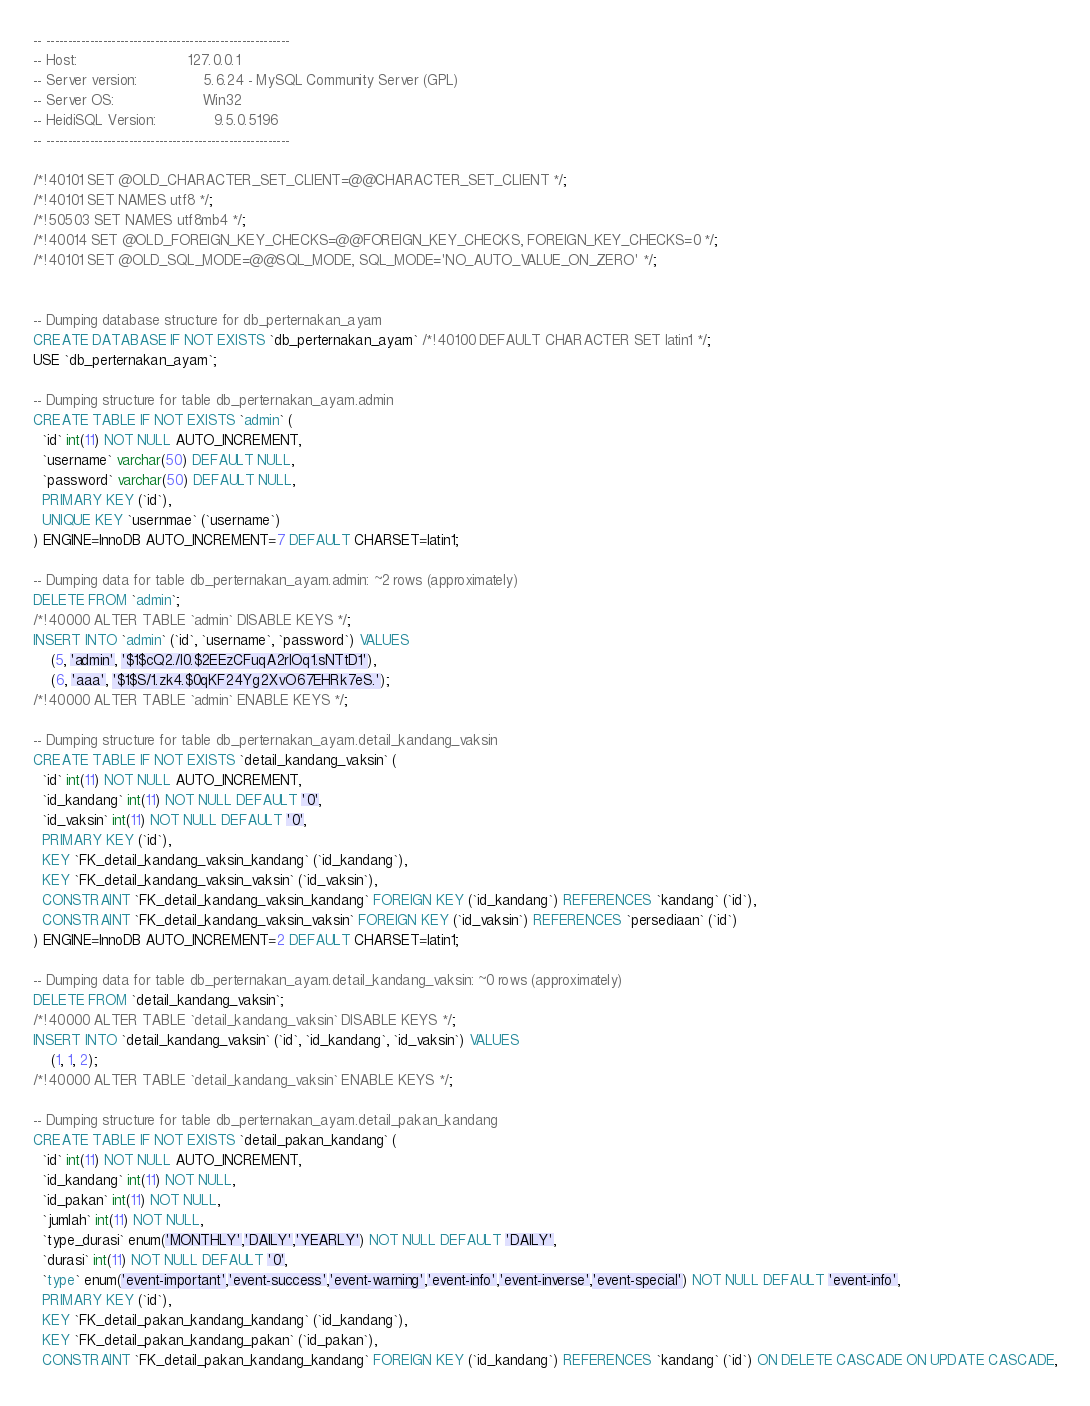Convert code to text. <code><loc_0><loc_0><loc_500><loc_500><_SQL_>-- --------------------------------------------------------
-- Host:                         127.0.0.1
-- Server version:               5.6.24 - MySQL Community Server (GPL)
-- Server OS:                    Win32
-- HeidiSQL Version:             9.5.0.5196
-- --------------------------------------------------------

/*!40101 SET @OLD_CHARACTER_SET_CLIENT=@@CHARACTER_SET_CLIENT */;
/*!40101 SET NAMES utf8 */;
/*!50503 SET NAMES utf8mb4 */;
/*!40014 SET @OLD_FOREIGN_KEY_CHECKS=@@FOREIGN_KEY_CHECKS, FOREIGN_KEY_CHECKS=0 */;
/*!40101 SET @OLD_SQL_MODE=@@SQL_MODE, SQL_MODE='NO_AUTO_VALUE_ON_ZERO' */;


-- Dumping database structure for db_perternakan_ayam
CREATE DATABASE IF NOT EXISTS `db_perternakan_ayam` /*!40100 DEFAULT CHARACTER SET latin1 */;
USE `db_perternakan_ayam`;

-- Dumping structure for table db_perternakan_ayam.admin
CREATE TABLE IF NOT EXISTS `admin` (
  `id` int(11) NOT NULL AUTO_INCREMENT,
  `username` varchar(50) DEFAULT NULL,
  `password` varchar(50) DEFAULT NULL,
  PRIMARY KEY (`id`),
  UNIQUE KEY `usernmae` (`username`)
) ENGINE=InnoDB AUTO_INCREMENT=7 DEFAULT CHARSET=latin1;

-- Dumping data for table db_perternakan_ayam.admin: ~2 rows (approximately)
DELETE FROM `admin`;
/*!40000 ALTER TABLE `admin` DISABLE KEYS */;
INSERT INTO `admin` (`id`, `username`, `password`) VALUES
	(5, 'admin', '$1$cQ2./l0.$2EEzCFuqA2rIOq1.sNTtD1'),
	(6, 'aaa', '$1$S/1.zk4.$0qKF24Yg2XvO67EHRk7eS.');
/*!40000 ALTER TABLE `admin` ENABLE KEYS */;

-- Dumping structure for table db_perternakan_ayam.detail_kandang_vaksin
CREATE TABLE IF NOT EXISTS `detail_kandang_vaksin` (
  `id` int(11) NOT NULL AUTO_INCREMENT,
  `id_kandang` int(11) NOT NULL DEFAULT '0',
  `id_vaksin` int(11) NOT NULL DEFAULT '0',
  PRIMARY KEY (`id`),
  KEY `FK_detail_kandang_vaksin_kandang` (`id_kandang`),
  KEY `FK_detail_kandang_vaksin_vaksin` (`id_vaksin`),
  CONSTRAINT `FK_detail_kandang_vaksin_kandang` FOREIGN KEY (`id_kandang`) REFERENCES `kandang` (`id`),
  CONSTRAINT `FK_detail_kandang_vaksin_vaksin` FOREIGN KEY (`id_vaksin`) REFERENCES `persediaan` (`id`)
) ENGINE=InnoDB AUTO_INCREMENT=2 DEFAULT CHARSET=latin1;

-- Dumping data for table db_perternakan_ayam.detail_kandang_vaksin: ~0 rows (approximately)
DELETE FROM `detail_kandang_vaksin`;
/*!40000 ALTER TABLE `detail_kandang_vaksin` DISABLE KEYS */;
INSERT INTO `detail_kandang_vaksin` (`id`, `id_kandang`, `id_vaksin`) VALUES
	(1, 1, 2);
/*!40000 ALTER TABLE `detail_kandang_vaksin` ENABLE KEYS */;

-- Dumping structure for table db_perternakan_ayam.detail_pakan_kandang
CREATE TABLE IF NOT EXISTS `detail_pakan_kandang` (
  `id` int(11) NOT NULL AUTO_INCREMENT,
  `id_kandang` int(11) NOT NULL,
  `id_pakan` int(11) NOT NULL,
  `jumlah` int(11) NOT NULL,
  `type_durasi` enum('MONTHLY','DAILY','YEARLY') NOT NULL DEFAULT 'DAILY',
  `durasi` int(11) NOT NULL DEFAULT '0',
  `type` enum('event-important','event-success','event-warning','event-info','event-inverse','event-special') NOT NULL DEFAULT 'event-info',
  PRIMARY KEY (`id`),
  KEY `FK_detail_pakan_kandang_kandang` (`id_kandang`),
  KEY `FK_detail_pakan_kandang_pakan` (`id_pakan`),
  CONSTRAINT `FK_detail_pakan_kandang_kandang` FOREIGN KEY (`id_kandang`) REFERENCES `kandang` (`id`) ON DELETE CASCADE ON UPDATE CASCADE,</code> 